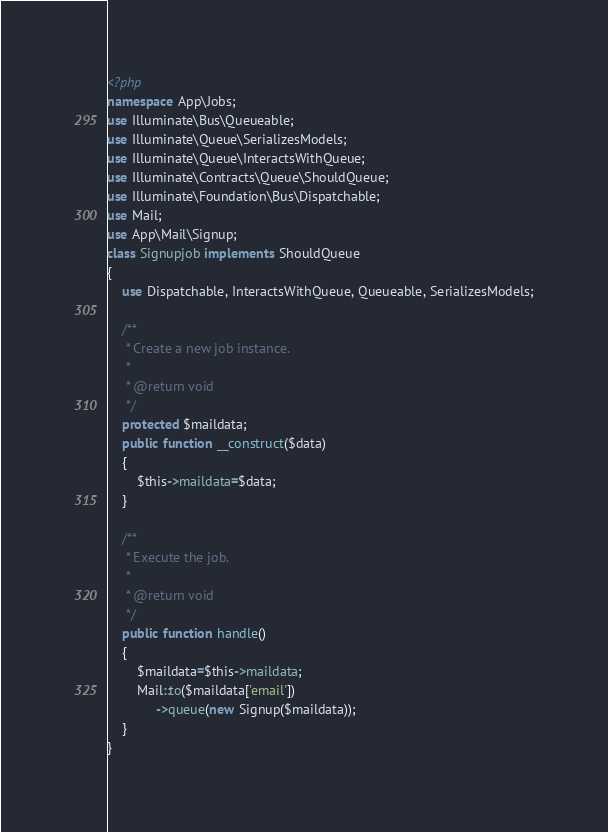<code> <loc_0><loc_0><loc_500><loc_500><_PHP_><?php
namespace App\Jobs;
use Illuminate\Bus\Queueable;
use Illuminate\Queue\SerializesModels;
use Illuminate\Queue\InteractsWithQueue;
use Illuminate\Contracts\Queue\ShouldQueue;
use Illuminate\Foundation\Bus\Dispatchable;
use Mail;
use App\Mail\Signup;
class Signupjob implements ShouldQueue
{
    use Dispatchable, InteractsWithQueue, Queueable, SerializesModels;

    /**
     * Create a new job instance.
     *
     * @return void
     */
    protected $maildata;
    public function __construct($data)
    {
        $this->maildata=$data;
    }

    /**
     * Execute the job.
     *
     * @return void
     */
    public function handle()
    {
        $maildata=$this->maildata;
        Mail::to($maildata['email'])
             ->queue(new Signup($maildata));
    }
}
</code> 